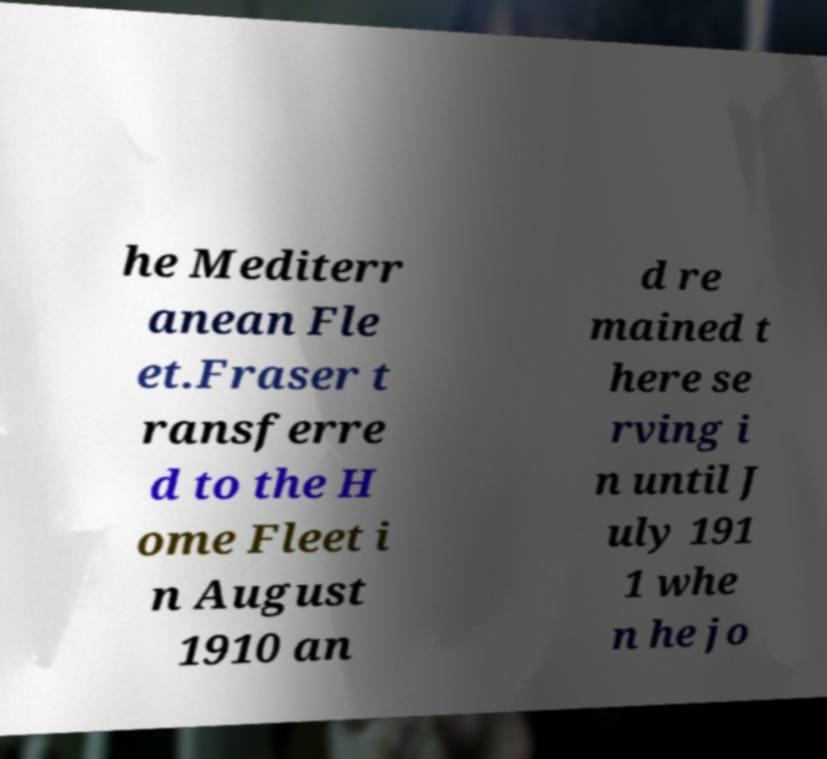Can you accurately transcribe the text from the provided image for me? he Mediterr anean Fle et.Fraser t ransferre d to the H ome Fleet i n August 1910 an d re mained t here se rving i n until J uly 191 1 whe n he jo 